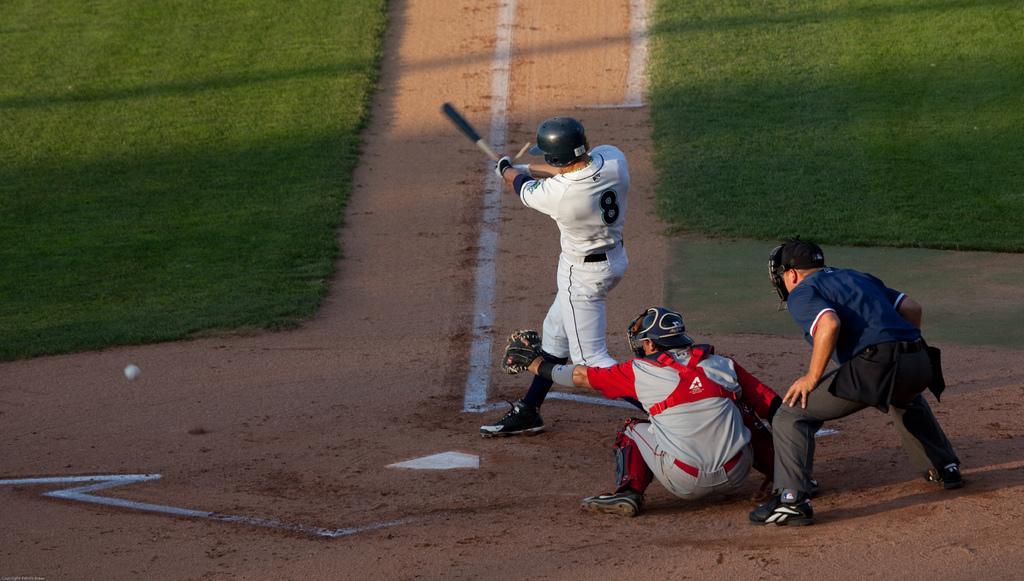Describe this image in one or two sentences. In the image we can see three men wearing clothes, shoes and two of them are wearing a helmet. There is a person holding a bat and wearing gloves. Here we can see ball, grass, sand and white lines on it 